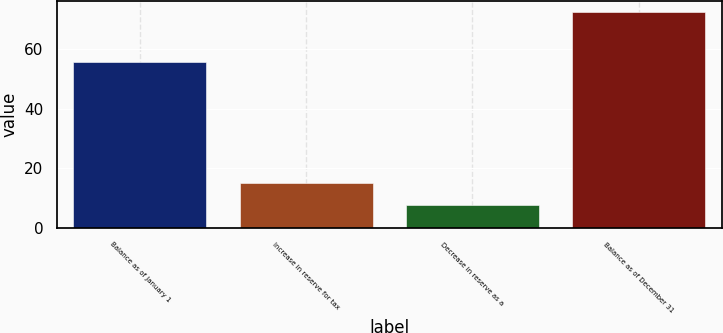Convert chart. <chart><loc_0><loc_0><loc_500><loc_500><bar_chart><fcel>Balance as of January 1<fcel>Increase in reserve for tax<fcel>Decrease in reserve as a<fcel>Balance as of December 31<nl><fcel>55.7<fcel>14.98<fcel>7.79<fcel>72.5<nl></chart> 